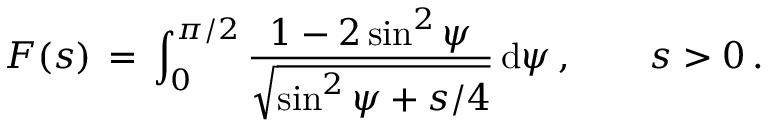<formula> <loc_0><loc_0><loc_500><loc_500>F ( s ) \, = \, \int _ { 0 } ^ { \pi / 2 } \frac { 1 - 2 \sin ^ { 2 } \psi } { \sqrt { \sin ^ { 2 } \psi + s / 4 } } \, d \psi \, , \quad s > 0 \, .</formula> 